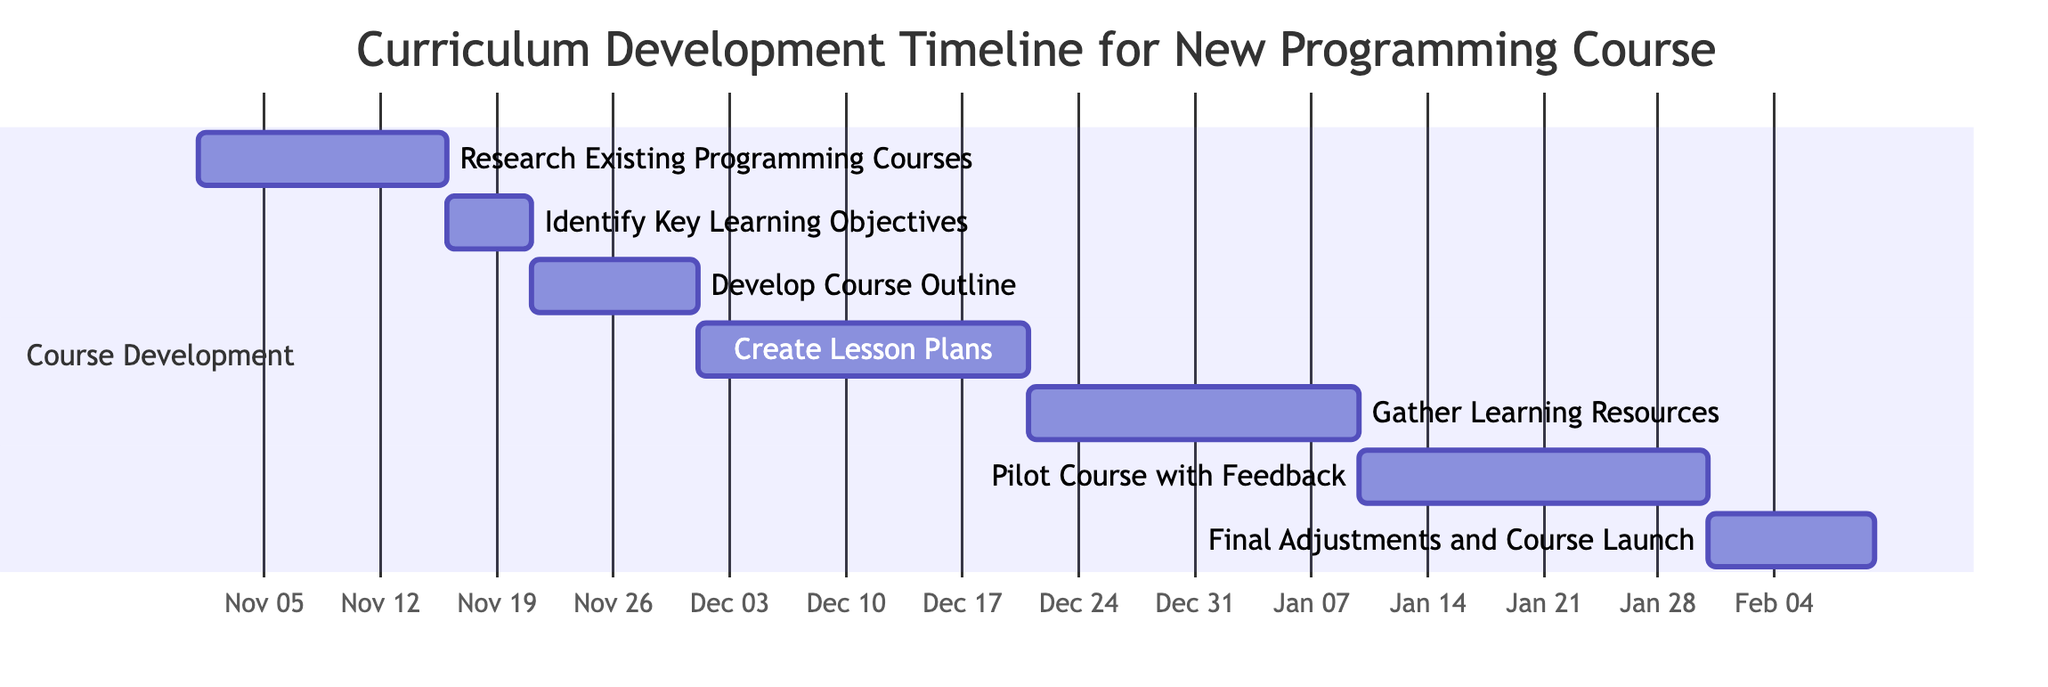What is the duration of the "Gather Learning Resources" task? The diagram specifies the duration of the "Gather Learning Resources" task directly, which is 20 days.
Answer: 20 days What is the starting date of the "Pilot Course with Feedback"? The diagram indicates that the "Pilot Course with Feedback" starts on January 11, 2024, as per the task details in the Gantt chart.
Answer: January 11, 2024 How many days does the "Create Lesson Plans" task last? According to the diagram, the "Create Lesson Plans" task lasts for 20 days, as noted beside this specific task.
Answer: 20 days What task comes after "Develop Course Outline"? The flow in the Gantt chart shows that the task that follows "Develop Course Outline" is "Create Lesson Plans".
Answer: Create Lesson Plans When does the course launch occur? The Gantt chart indicates that the "Final Adjustments and Course Launch" occurs on February 10, 2024, as shown in the timeline for that task.
Answer: February 10, 2024 What is the total number of tasks outlined in the Gantt chart? Counting each task listed in the diagram, there are seven tasks that make up the curriculum development timeline.
Answer: 7 Which task has the shortest duration in the Gantt chart? By analyzing the durations of all tasks in the chart, the "Identify Key Learning Objectives" task has the shortest duration of 5 days.
Answer: 5 days How many days are there between the end of the "Create Lesson Plans" and the start of the "Gather Learning Resources"? The "Create Lesson Plans" ends on December 20, 2023, and "Gather Learning Resources" starts on December 21, 2023, resulting in a day gap between these two tasks.
Answer: 1 day What task is preceded by the "Research Existing Programming Courses"? Based on the sequence of tasks in the Gantt chart, "Identify Key Learning Objectives" is the task that follows "Research Existing Programming Courses".
Answer: Identify Key Learning Objectives 